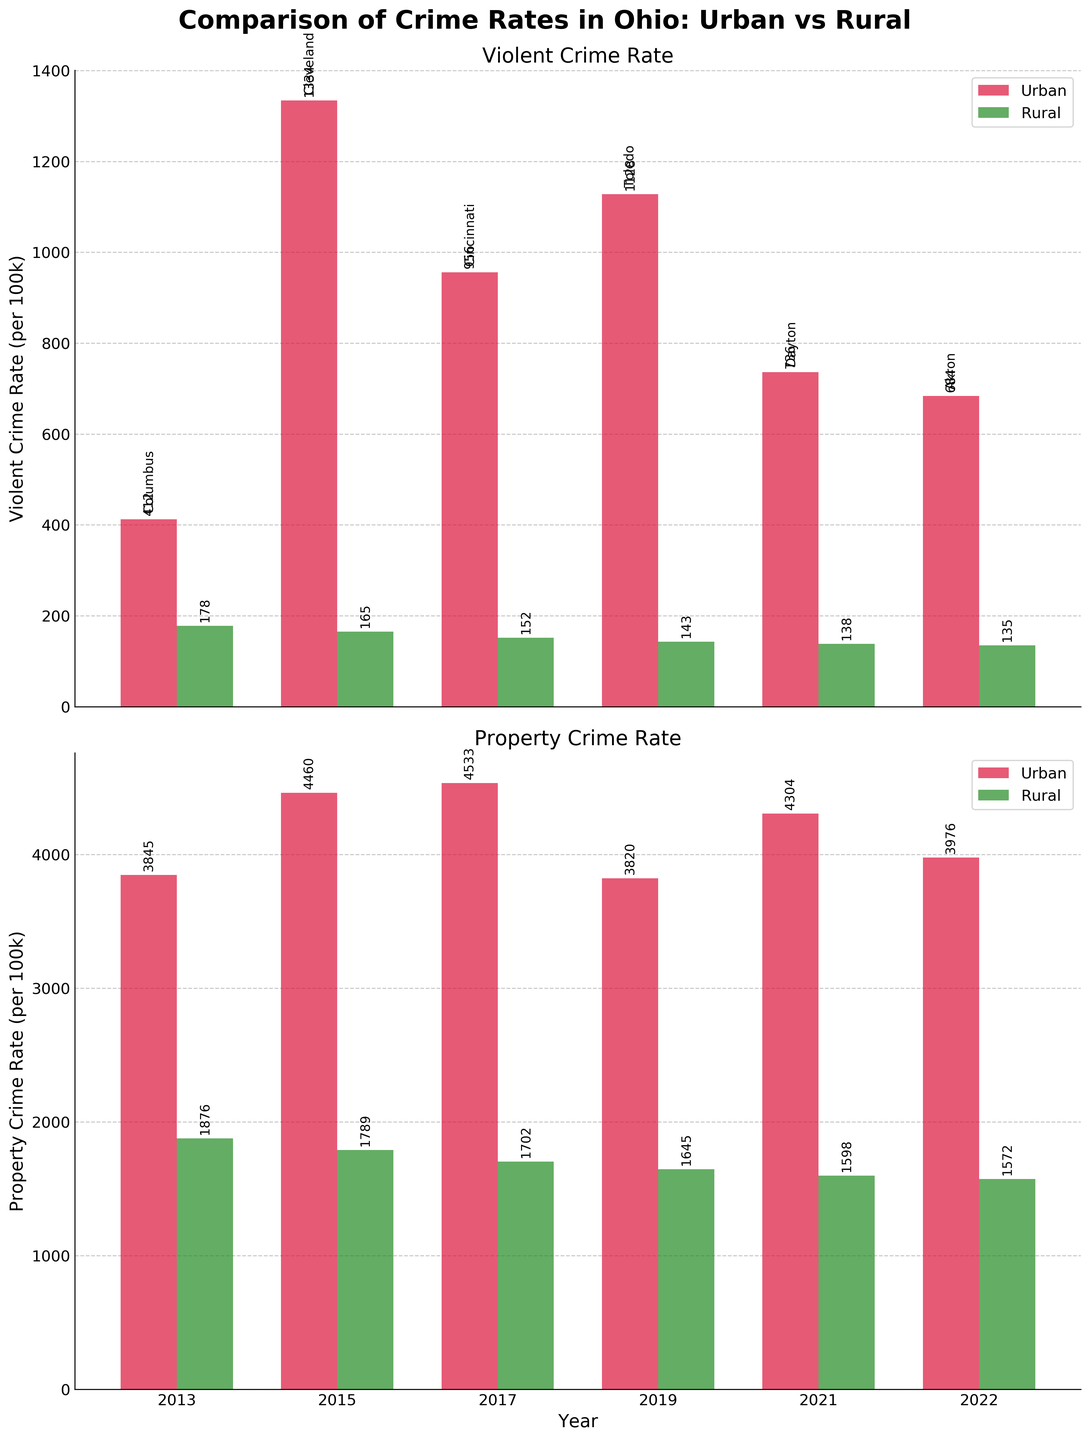Which year had the highest violent crime rate in urban areas? To find the year with the highest violent crime rate in urban areas, look for the tallest red bars in the first bar chart. The tallest bar is in 2015.
Answer: 2015 How does the violent crime rate in rural Ohio in 2013 compare to 2022? Check the height of the green bars for rural Ohio in 2013 and 2022 in the first bar chart. Both bars are of similar height with values 178 and 135, respectively, indicating a decrease.
Answer: Decreased Which location had the lowest property crime rate in 2019? For property crime rates in 2019, compare the heights of the red bar (Toledo) and the green bar (Rural Ohio) in the second bar chart. The green bar representing Rural Ohio is shorter.
Answer: Rural Ohio What is the average violent crime rate for rural Ohio over the decade? To calculate the average, sum the violent crime rates for rural Ohio across all years (178 + 165 + 152 + 143 + 138 + 135) and divide by the number of years (6). The calculation is (178+165+152+143+138+135) / 6 = 152.17.
Answer: 152.17 Compare the property crime rates in Akron in 2022 with the rural Ohio property crime rate in the same year. Look at the heights of the bars for Akron and Rural Ohio in 2022 in the second chart. The red bar (Akron) is significantly taller than the green bar (Rural Ohio), with values 3976 and 1572, respectively.
Answer: Akron higher Does Cincinnati have a higher or lower violent crime rate than Toledo in their respective years shown? Find the red bars corresponding to Cincinnati (2017) and Toledo (2019) in the first chart. The bar for Toledo is taller (1128) compared to Cincinnati (956). Therefore, Cincinnati has a lower violent crime rate.
Answer: Lower What is the median property crime rate for urban areas over the decade? List the property crime rates for urban areas (3845, 4460, 4533, 3820, 4304, 3976) and find the median. Since there are an even number of values, the median is the average of the 3rd and 4th values when sorted (3820, 3845, 3976, 4304, 4460, 4533). The median is (3976+4304)/2 = 4140.
Answer: 4140 By how much did the violent crime rate in Cleveland in 2015 exceed the rate in Columbus in 2013? Subtract the violent crime rate for Columbus in 2013 (412) from that of Cleveland in 2015 (1334). The difference is 1334 - 412 = 922.
Answer: 922 What trend can be observed about the property crime rate in rural Ohio from 2013 to 2022? Look at the green bar heights in the second chart for rural Ohio from 2013 to 2022. The heights show a decreasing trend from 1876 to 1572 over the decade.
Answer: Decreasing Was the property crime rate higher in Columbus in 2013 or in Dayton in 2021? Compare the heights of the red bars for Columbus (2013) and Dayton (2021) in the second chart. Dayton (4304) has a taller bar than Columbus (3845), indicating a higher property crime rate.
Answer: Dayton in 2021 